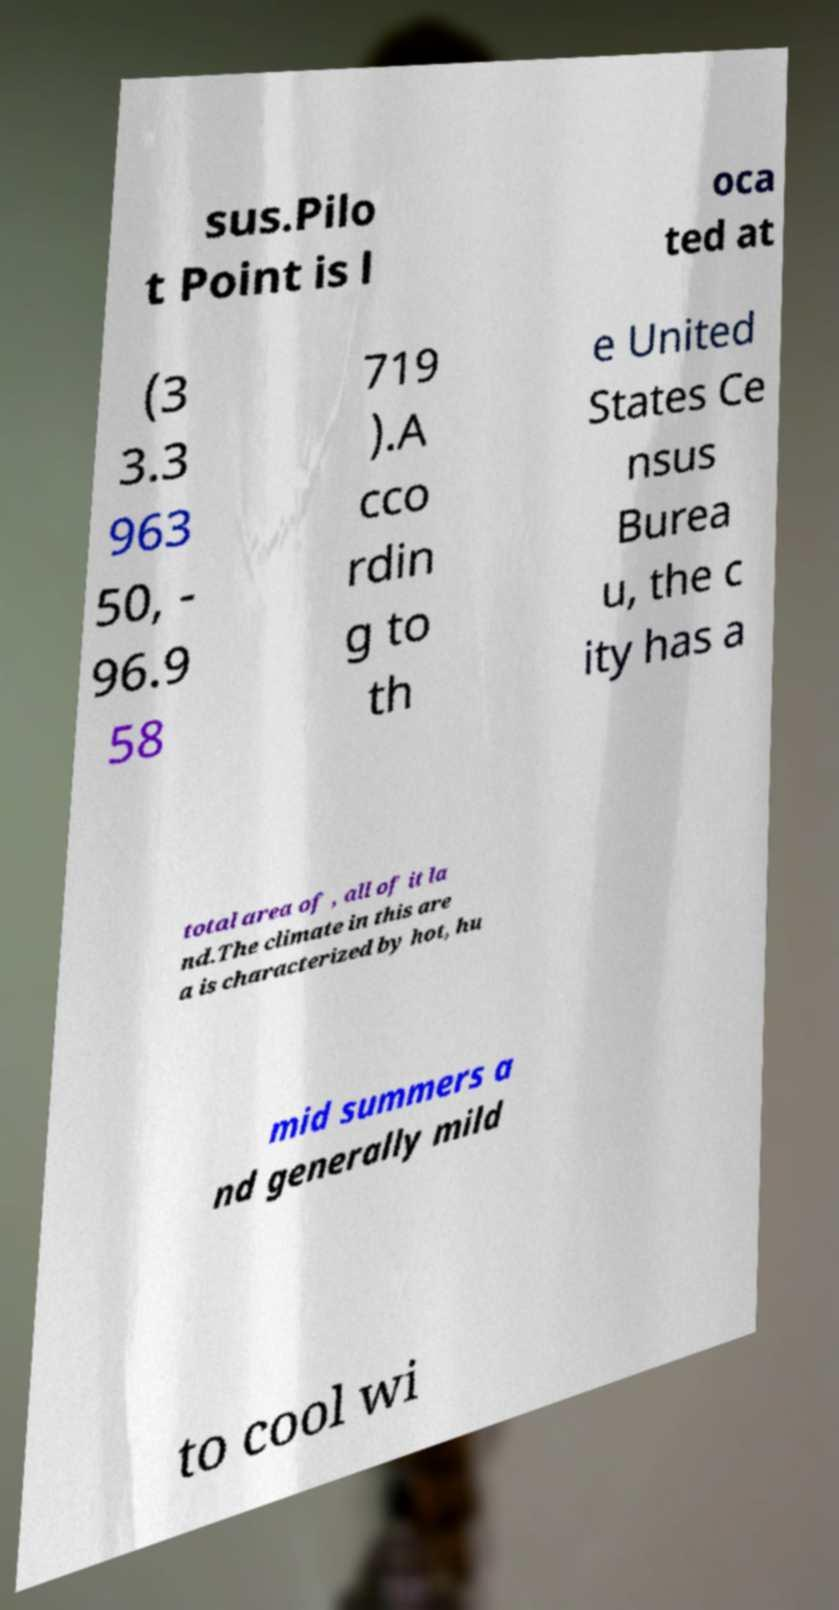Can you read and provide the text displayed in the image?This photo seems to have some interesting text. Can you extract and type it out for me? sus.Pilo t Point is l oca ted at (3 3.3 963 50, - 96.9 58 719 ).A cco rdin g to th e United States Ce nsus Burea u, the c ity has a total area of , all of it la nd.The climate in this are a is characterized by hot, hu mid summers a nd generally mild to cool wi 